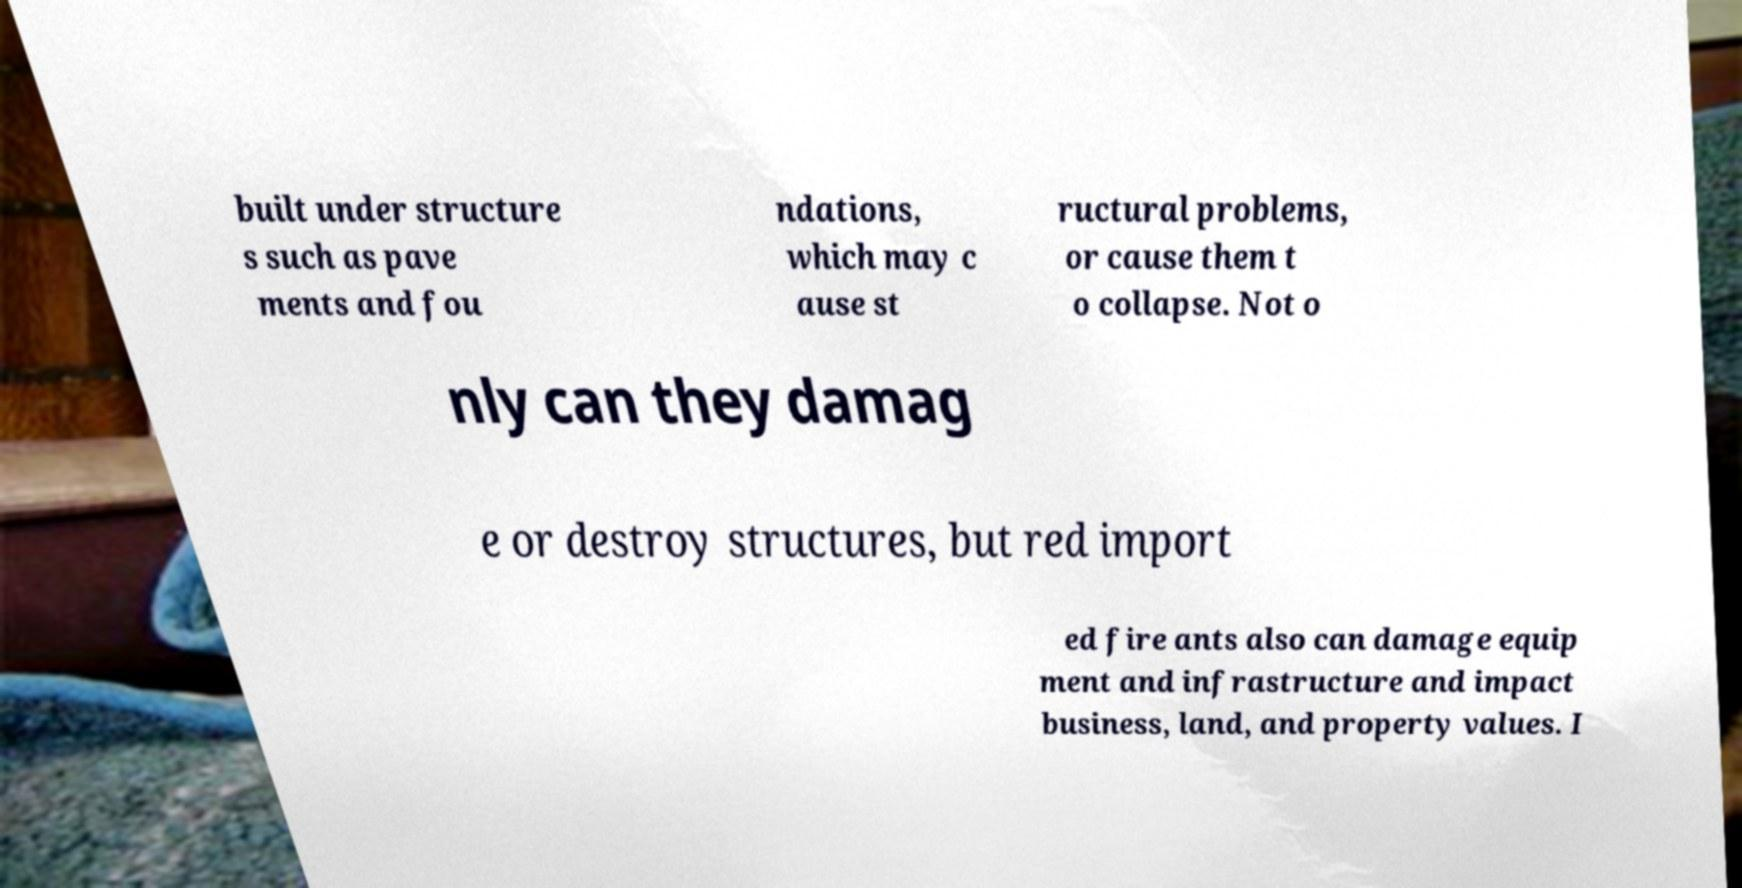For documentation purposes, I need the text within this image transcribed. Could you provide that? built under structure s such as pave ments and fou ndations, which may c ause st ructural problems, or cause them t o collapse. Not o nly can they damag e or destroy structures, but red import ed fire ants also can damage equip ment and infrastructure and impact business, land, and property values. I 